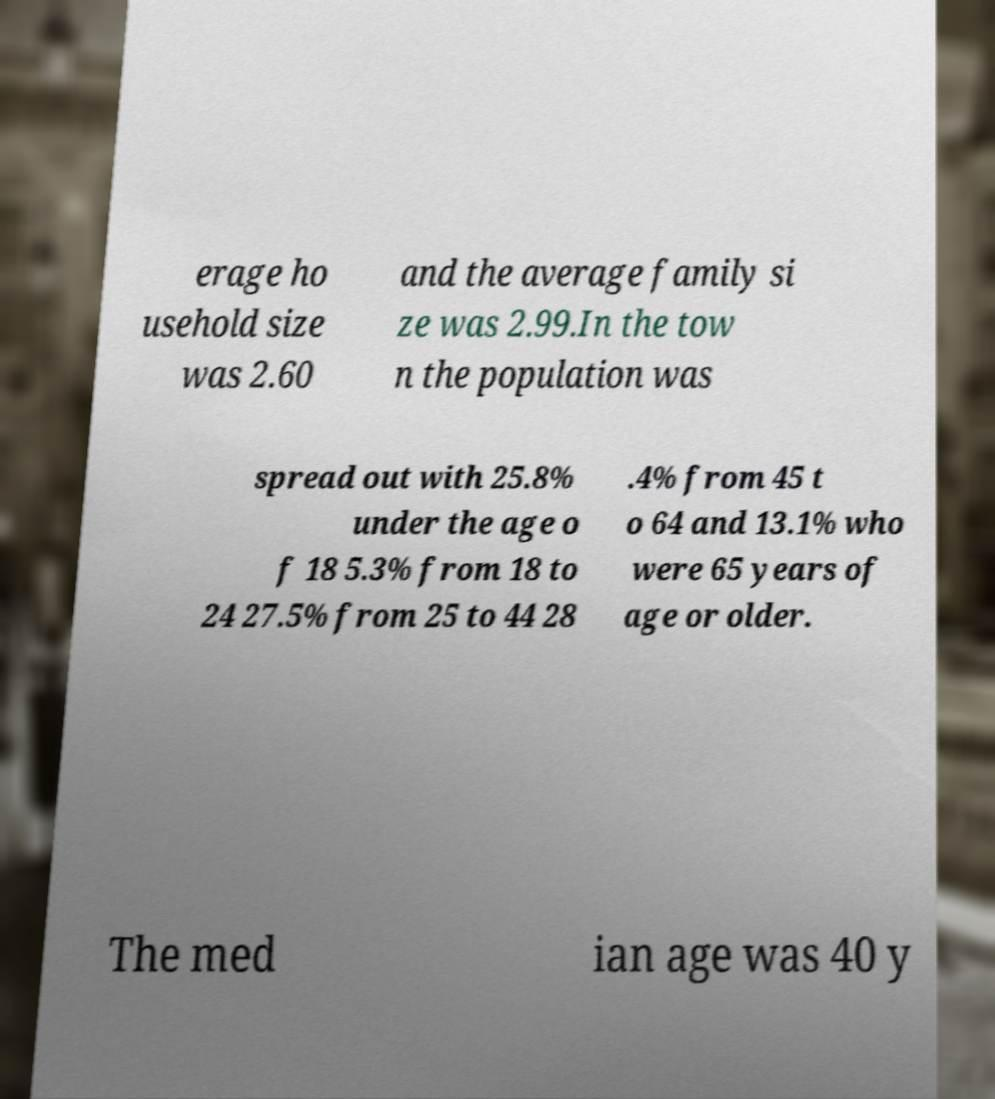I need the written content from this picture converted into text. Can you do that? erage ho usehold size was 2.60 and the average family si ze was 2.99.In the tow n the population was spread out with 25.8% under the age o f 18 5.3% from 18 to 24 27.5% from 25 to 44 28 .4% from 45 t o 64 and 13.1% who were 65 years of age or older. The med ian age was 40 y 